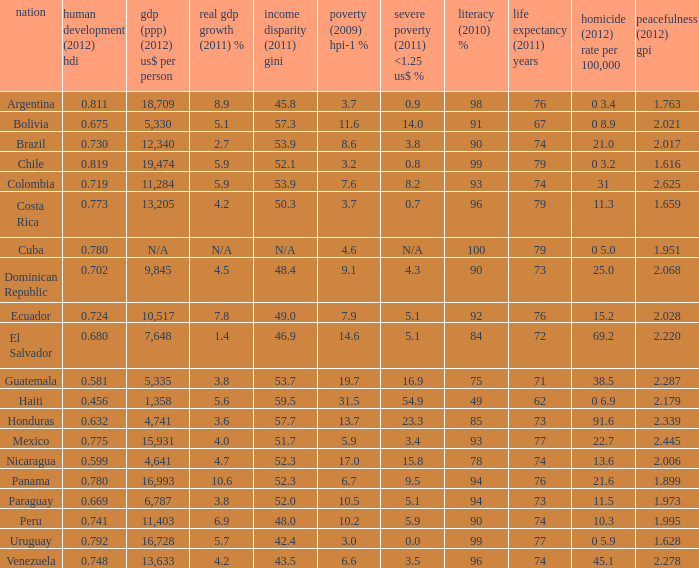What is the total poverty (2009) HPI-1 % when the extreme poverty (2011) <1.25 US$ % of 16.9, and the human development (2012) HDI is less than 0.581? None. 